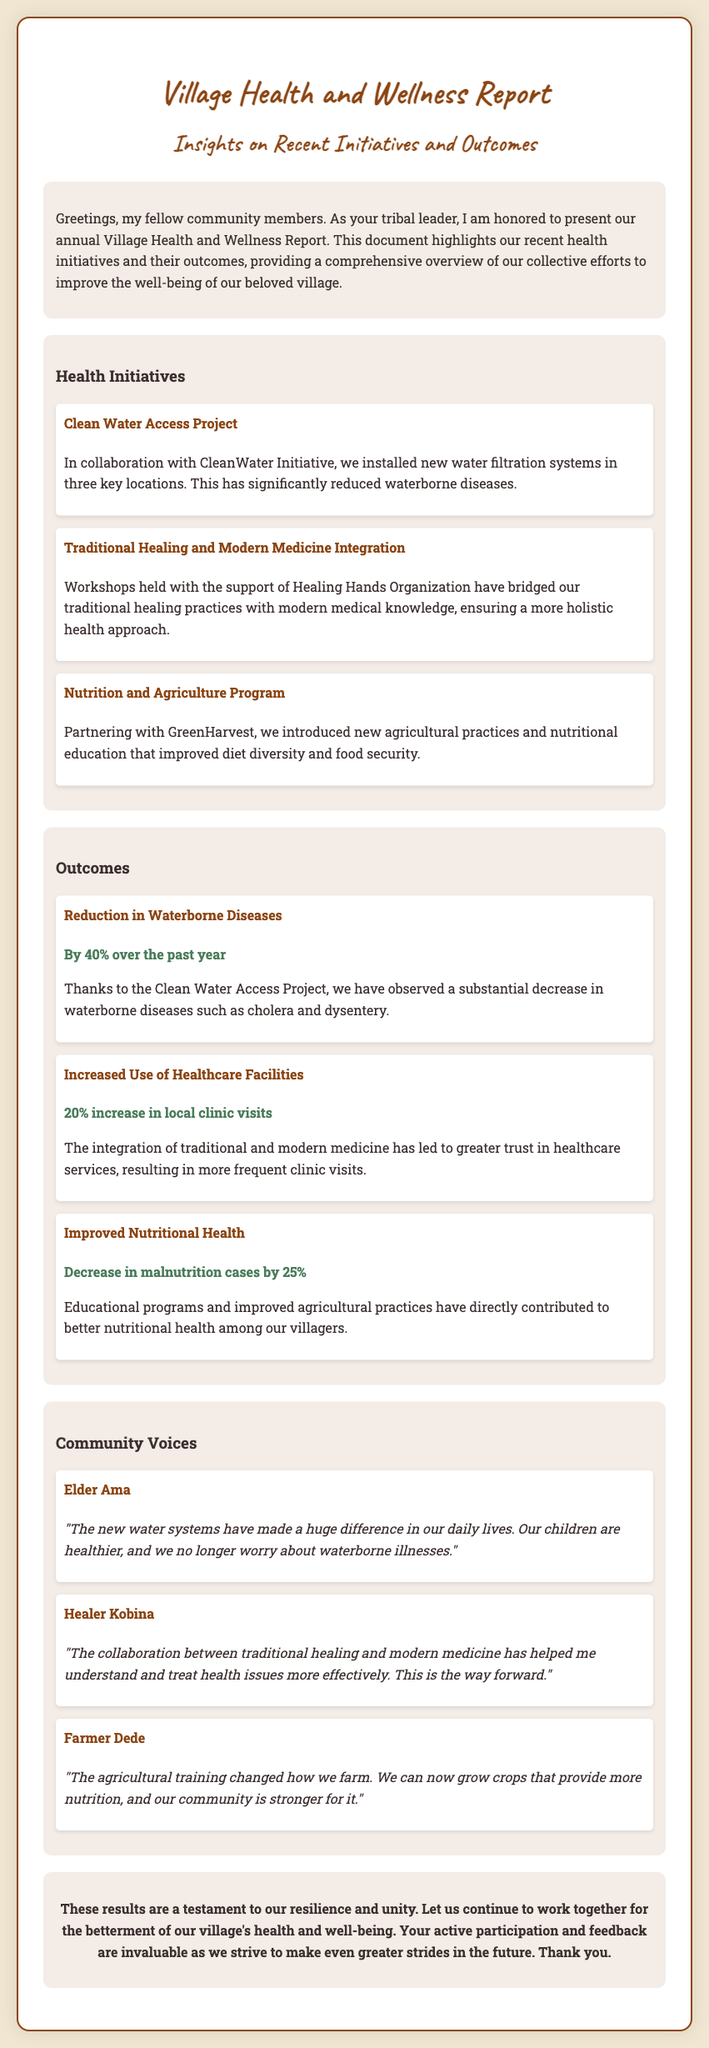What is the title of the report? The title of the report is stated in the header section of the document.
Answer: Village Health and Wellness Report How many health initiatives are mentioned in the report? The document lists the number of health initiatives under the "Health Initiatives" section.
Answer: Three What percentage reduction was observed in waterborne diseases? The report specifies the percentage decrease in waterborne diseases under the "Outcomes" section.
Answer: By 40% Who collaborated on the Clean Water Access Project? The collaboration details are mentioned with the project in the "Health Initiatives" section.
Answer: CleanWater Initiative What is the outcome regarding malnutrition cases? The report explicitly states the change in malnutrition cases under the "Outcomes" section.
Answer: Decrease in malnutrition cases by 25% What significant increase in clinic visits was noted in the report? The document provides specific information about the change in clinic visits in the "Outcomes" section.
Answer: 20% increase in local clinic visits Which organization helped bridge traditional and modern medicine? The supporting organization is mentioned in the "Health Initiatives" section related to workshops.
Answer: Healing Hands Organization Who is quoted saying the new water systems made a difference in daily lives? The testimonial section includes specific speakers, revealing who made that statement.
Answer: Elder Ama 